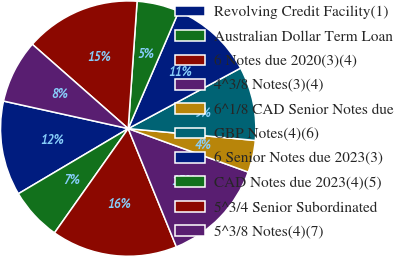Convert chart to OTSL. <chart><loc_0><loc_0><loc_500><loc_500><pie_chart><fcel>Revolving Credit Facility(1)<fcel>Australian Dollar Term Loan<fcel>6 Notes due 2020(3)(4)<fcel>4^3/8 Notes(3)(4)<fcel>6^1/8 CAD Senior Notes due<fcel>GBP Notes(4)(6)<fcel>6 Senior Notes due 2023(3)<fcel>CAD Notes due 2023(4)(5)<fcel>5^3/4 Senior Subordinated<fcel>5^3/8 Notes(4)(7)<nl><fcel>11.98%<fcel>6.69%<fcel>15.95%<fcel>13.31%<fcel>4.05%<fcel>9.34%<fcel>10.66%<fcel>5.37%<fcel>14.63%<fcel>8.02%<nl></chart> 